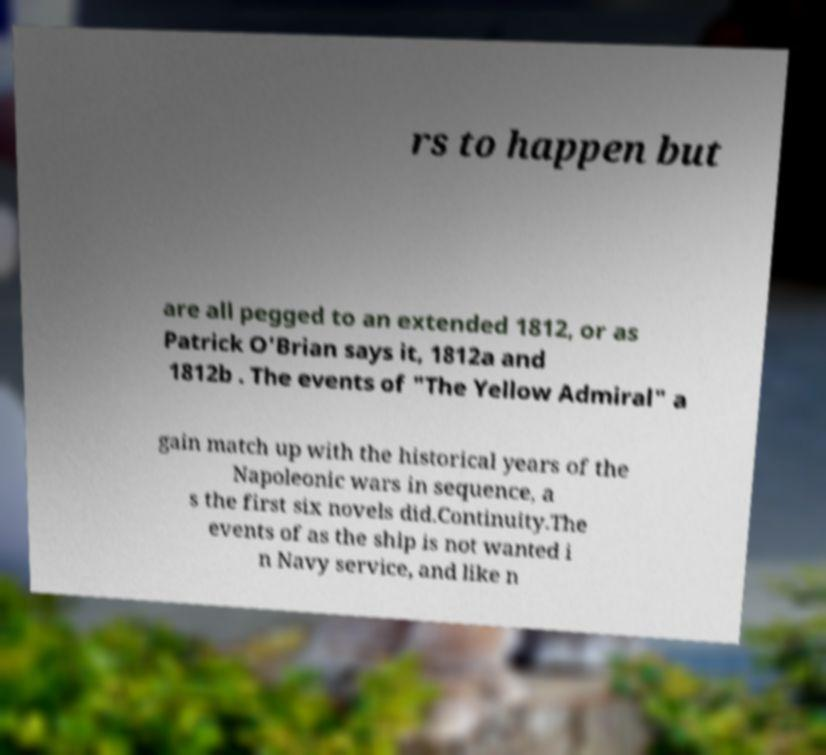Can you read and provide the text displayed in the image?This photo seems to have some interesting text. Can you extract and type it out for me? rs to happen but are all pegged to an extended 1812, or as Patrick O'Brian says it, 1812a and 1812b . The events of "The Yellow Admiral" a gain match up with the historical years of the Napoleonic wars in sequence, a s the first six novels did.Continuity.The events of as the ship is not wanted i n Navy service, and like n 